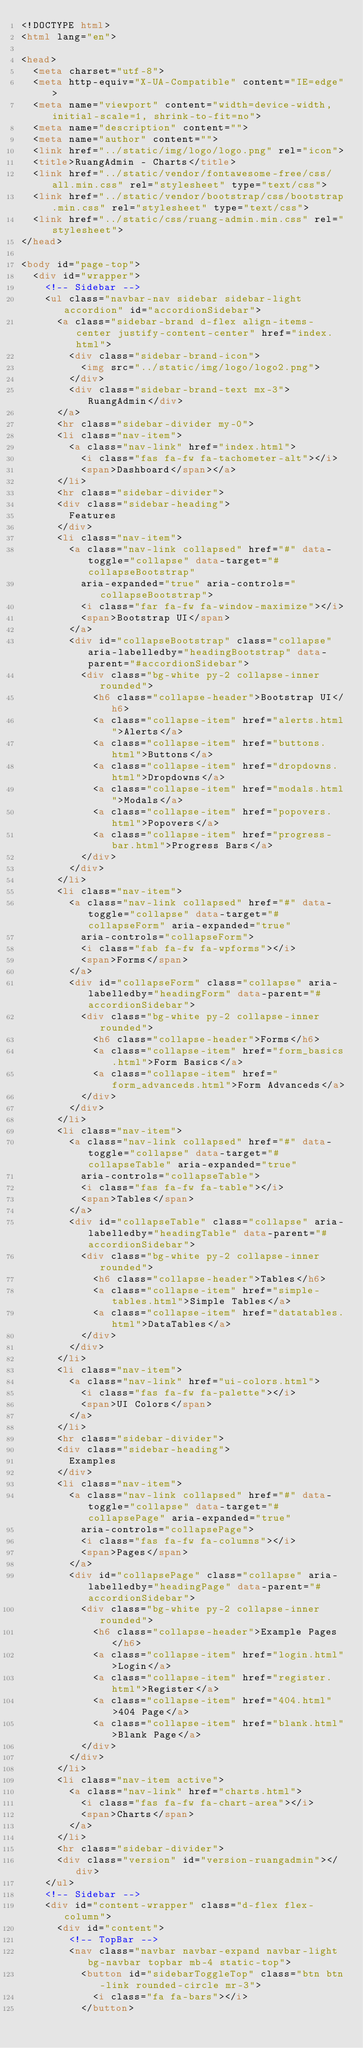Convert code to text. <code><loc_0><loc_0><loc_500><loc_500><_HTML_><!DOCTYPE html>
<html lang="en">

<head>
  <meta charset="utf-8">
  <meta http-equiv="X-UA-Compatible" content="IE=edge">
  <meta name="viewport" content="width=device-width, initial-scale=1, shrink-to-fit=no">
  <meta name="description" content="">
  <meta name="author" content="">
  <link href="../static/img/logo/logo.png" rel="icon">
  <title>RuangAdmin - Charts</title>
  <link href="../static/vendor/fontawesome-free/css/all.min.css" rel="stylesheet" type="text/css">
  <link href="../static/vendor/bootstrap/css/bootstrap.min.css" rel="stylesheet" type="text/css">
  <link href="../static/css/ruang-admin.min.css" rel="stylesheet">
</head>

<body id="page-top">
  <div id="wrapper">
    <!-- Sidebar -->
    <ul class="navbar-nav sidebar sidebar-light accordion" id="accordionSidebar">
      <a class="sidebar-brand d-flex align-items-center justify-content-center" href="index.html">
        <div class="sidebar-brand-icon">
          <img src="../static/img/logo/logo2.png">
        </div>
        <div class="sidebar-brand-text mx-3">RuangAdmin</div>
      </a>
      <hr class="sidebar-divider my-0">
      <li class="nav-item">
        <a class="nav-link" href="index.html">
          <i class="fas fa-fw fa-tachometer-alt"></i>
          <span>Dashboard</span></a>
      </li>
      <hr class="sidebar-divider">
      <div class="sidebar-heading">
        Features
      </div>
      <li class="nav-item">
        <a class="nav-link collapsed" href="#" data-toggle="collapse" data-target="#collapseBootstrap"
          aria-expanded="true" aria-controls="collapseBootstrap">
          <i class="far fa-fw fa-window-maximize"></i>
          <span>Bootstrap UI</span>
        </a>
        <div id="collapseBootstrap" class="collapse" aria-labelledby="headingBootstrap" data-parent="#accordionSidebar">
          <div class="bg-white py-2 collapse-inner rounded">
            <h6 class="collapse-header">Bootstrap UI</h6>
            <a class="collapse-item" href="alerts.html">Alerts</a>
            <a class="collapse-item" href="buttons.html">Buttons</a>
            <a class="collapse-item" href="dropdowns.html">Dropdowns</a>
            <a class="collapse-item" href="modals.html">Modals</a>
            <a class="collapse-item" href="popovers.html">Popovers</a>
            <a class="collapse-item" href="progress-bar.html">Progress Bars</a>
          </div>
        </div>
      </li>
      <li class="nav-item">
        <a class="nav-link collapsed" href="#" data-toggle="collapse" data-target="#collapseForm" aria-expanded="true"
          aria-controls="collapseForm">
          <i class="fab fa-fw fa-wpforms"></i>
          <span>Forms</span>
        </a>
        <div id="collapseForm" class="collapse" aria-labelledby="headingForm" data-parent="#accordionSidebar">
          <div class="bg-white py-2 collapse-inner rounded">
            <h6 class="collapse-header">Forms</h6>
            <a class="collapse-item" href="form_basics.html">Form Basics</a>
            <a class="collapse-item" href="form_advanceds.html">Form Advanceds</a>
          </div>
        </div>
      </li>
      <li class="nav-item">
        <a class="nav-link collapsed" href="#" data-toggle="collapse" data-target="#collapseTable" aria-expanded="true"
          aria-controls="collapseTable">
          <i class="fas fa-fw fa-table"></i>
          <span>Tables</span>
        </a>
        <div id="collapseTable" class="collapse" aria-labelledby="headingTable" data-parent="#accordionSidebar">
          <div class="bg-white py-2 collapse-inner rounded">
            <h6 class="collapse-header">Tables</h6>
            <a class="collapse-item" href="simple-tables.html">Simple Tables</a>
            <a class="collapse-item" href="datatables.html">DataTables</a>
          </div>
        </div>
      </li>
      <li class="nav-item">
        <a class="nav-link" href="ui-colors.html">
          <i class="fas fa-fw fa-palette"></i>
          <span>UI Colors</span>
        </a>
      </li>
      <hr class="sidebar-divider">
      <div class="sidebar-heading">
        Examples
      </div>
      <li class="nav-item">
        <a class="nav-link collapsed" href="#" data-toggle="collapse" data-target="#collapsePage" aria-expanded="true"
          aria-controls="collapsePage">
          <i class="fas fa-fw fa-columns"></i>
          <span>Pages</span>
        </a>
        <div id="collapsePage" class="collapse" aria-labelledby="headingPage" data-parent="#accordionSidebar">
          <div class="bg-white py-2 collapse-inner rounded">
            <h6 class="collapse-header">Example Pages</h6>
            <a class="collapse-item" href="login.html">Login</a>
            <a class="collapse-item" href="register.html">Register</a>
            <a class="collapse-item" href="404.html">404 Page</a>
            <a class="collapse-item" href="blank.html">Blank Page</a>
          </div>
        </div>
      </li>
      <li class="nav-item active">
        <a class="nav-link" href="charts.html">
          <i class="fas fa-fw fa-chart-area"></i>
          <span>Charts</span>
        </a>
      </li>
      <hr class="sidebar-divider">
      <div class="version" id="version-ruangadmin"></div>
    </ul>
    <!-- Sidebar -->
    <div id="content-wrapper" class="d-flex flex-column">
      <div id="content">
        <!-- TopBar -->
        <nav class="navbar navbar-expand navbar-light bg-navbar topbar mb-4 static-top">
          <button id="sidebarToggleTop" class="btn btn-link rounded-circle mr-3">
            <i class="fa fa-bars"></i>
          </button></code> 